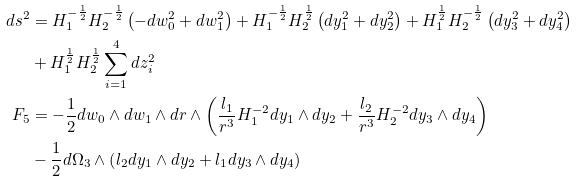<formula> <loc_0><loc_0><loc_500><loc_500>d s ^ { 2 } & = H _ { 1 } ^ { - \frac { 1 } { 2 } } H _ { 2 } ^ { - \frac { 1 } { 2 } } \left ( - d w _ { 0 } ^ { 2 } + d w _ { 1 } ^ { 2 } \right ) + H _ { 1 } ^ { - \frac { 1 } { 2 } } H _ { 2 } ^ { \frac { 1 } { 2 } } \left ( d y _ { 1 } ^ { 2 } + d y _ { 2 } ^ { 2 } \right ) + H _ { 1 } ^ { \frac { 1 } { 2 } } H _ { 2 } ^ { - \frac { 1 } { 2 } } \left ( d y _ { 3 } ^ { 2 } + d y _ { 4 } ^ { 2 } \right ) \\ & + H _ { 1 } ^ { \frac { 1 } { 2 } } H _ { 2 } ^ { \frac { 1 } { 2 } } \sum _ { i = 1 } ^ { 4 } d z _ { i } ^ { 2 } \\ F _ { 5 } & = - \frac { 1 } { 2 } d w _ { 0 } \wedge d w _ { 1 } \wedge d r \wedge \left ( \frac { l _ { 1 } } { r ^ { 3 } } H _ { 1 } ^ { - 2 } d y _ { 1 } \wedge d y _ { 2 } + \frac { l _ { 2 } } { r ^ { 3 } } H _ { 2 } ^ { - 2 } d y _ { 3 } \wedge d y _ { 4 } \right ) \\ & - \frac { 1 } { 2 } d \Omega _ { 3 } \wedge \left ( l _ { 2 } d y _ { 1 } \wedge d y _ { 2 } + l _ { 1 } d y _ { 3 } \wedge d y _ { 4 } \right )</formula> 